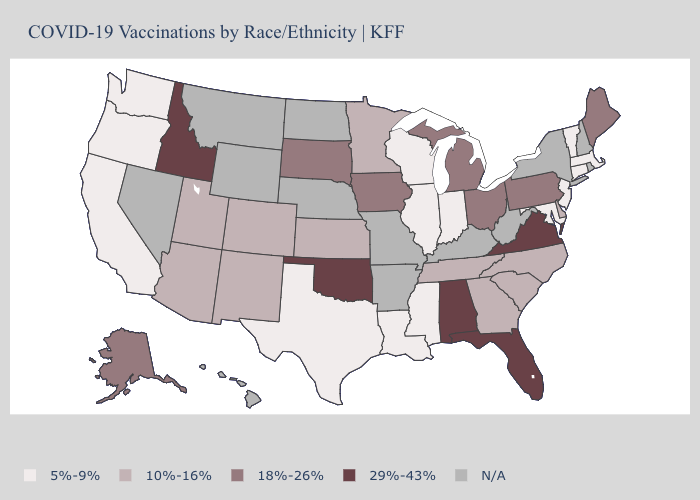Name the states that have a value in the range 18%-26%?
Answer briefly. Alaska, Iowa, Maine, Michigan, Ohio, Pennsylvania, South Dakota. What is the lowest value in the USA?
Quick response, please. 5%-9%. Does Arizona have the lowest value in the West?
Quick response, please. No. Is the legend a continuous bar?
Concise answer only. No. What is the value of Iowa?
Write a very short answer. 18%-26%. Which states have the highest value in the USA?
Short answer required. Alabama, Florida, Idaho, Oklahoma, Virginia. How many symbols are there in the legend?
Short answer required. 5. How many symbols are there in the legend?
Keep it brief. 5. What is the highest value in the South ?
Be succinct. 29%-43%. Which states have the lowest value in the USA?
Concise answer only. California, Connecticut, Illinois, Indiana, Louisiana, Maryland, Massachusetts, Mississippi, New Jersey, Oregon, Texas, Vermont, Washington, Wisconsin. What is the value of Hawaii?
Keep it brief. N/A. Name the states that have a value in the range 29%-43%?
Short answer required. Alabama, Florida, Idaho, Oklahoma, Virginia. What is the highest value in the MidWest ?
Short answer required. 18%-26%. Name the states that have a value in the range 18%-26%?
Write a very short answer. Alaska, Iowa, Maine, Michigan, Ohio, Pennsylvania, South Dakota. 